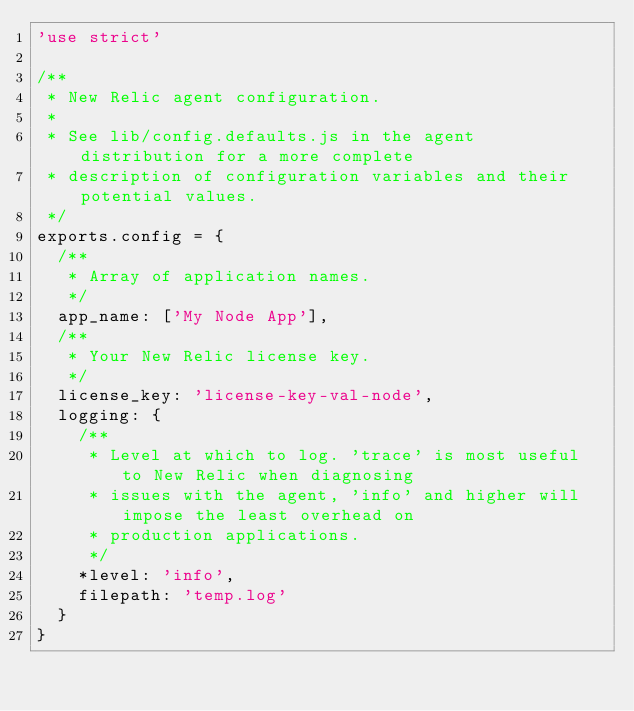Convert code to text. <code><loc_0><loc_0><loc_500><loc_500><_JavaScript_>'use strict'

/**
 * New Relic agent configuration.
 *
 * See lib/config.defaults.js in the agent distribution for a more complete
 * description of configuration variables and their potential values.
 */
exports.config = { 
  /**
   * Array of application names.
   */
  app_name: ['My Node App'],
  /**
   * Your New Relic license key.
   */
  license_key: 'license-key-val-node',
  logging: {
    /**
     * Level at which to log. 'trace' is most useful to New Relic when diagnosing
     * issues with the agent, 'info' and higher will impose the least overhead on
     * production applications.
     */
    *level: 'info',
    filepath: 'temp.log'
  }
}
</code> 